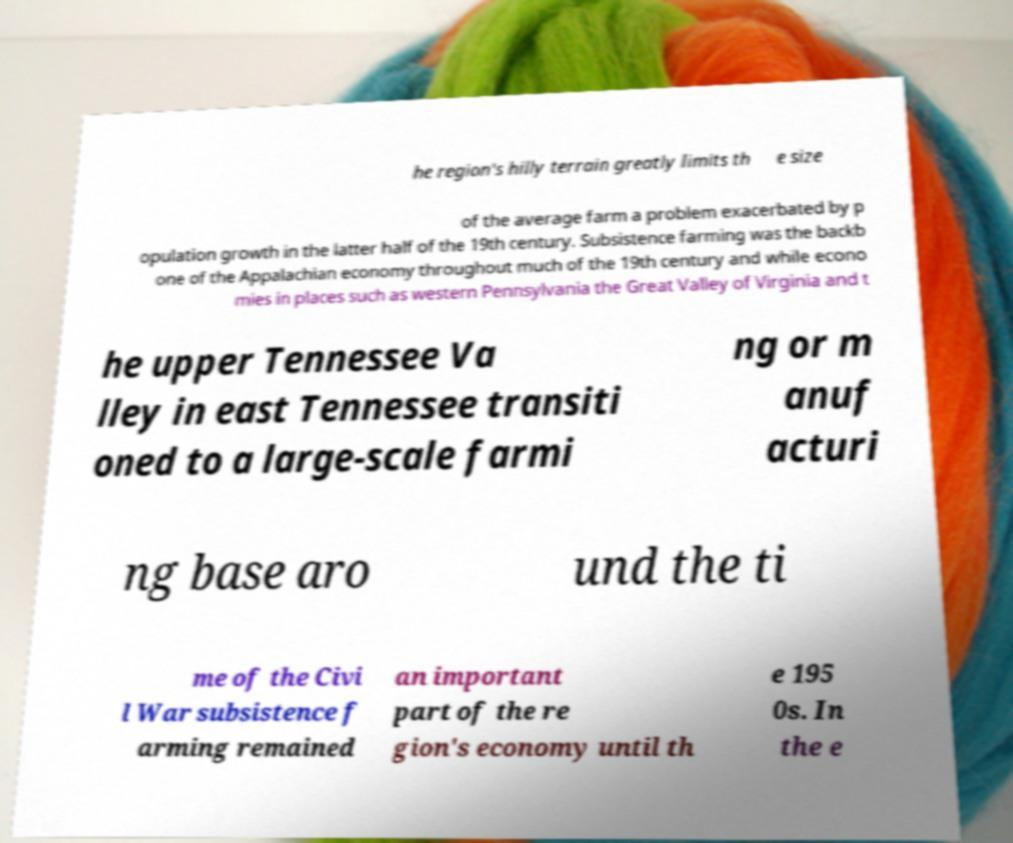Could you extract and type out the text from this image? he region's hilly terrain greatly limits th e size of the average farm a problem exacerbated by p opulation growth in the latter half of the 19th century. Subsistence farming was the backb one of the Appalachian economy throughout much of the 19th century and while econo mies in places such as western Pennsylvania the Great Valley of Virginia and t he upper Tennessee Va lley in east Tennessee transiti oned to a large-scale farmi ng or m anuf acturi ng base aro und the ti me of the Civi l War subsistence f arming remained an important part of the re gion's economy until th e 195 0s. In the e 